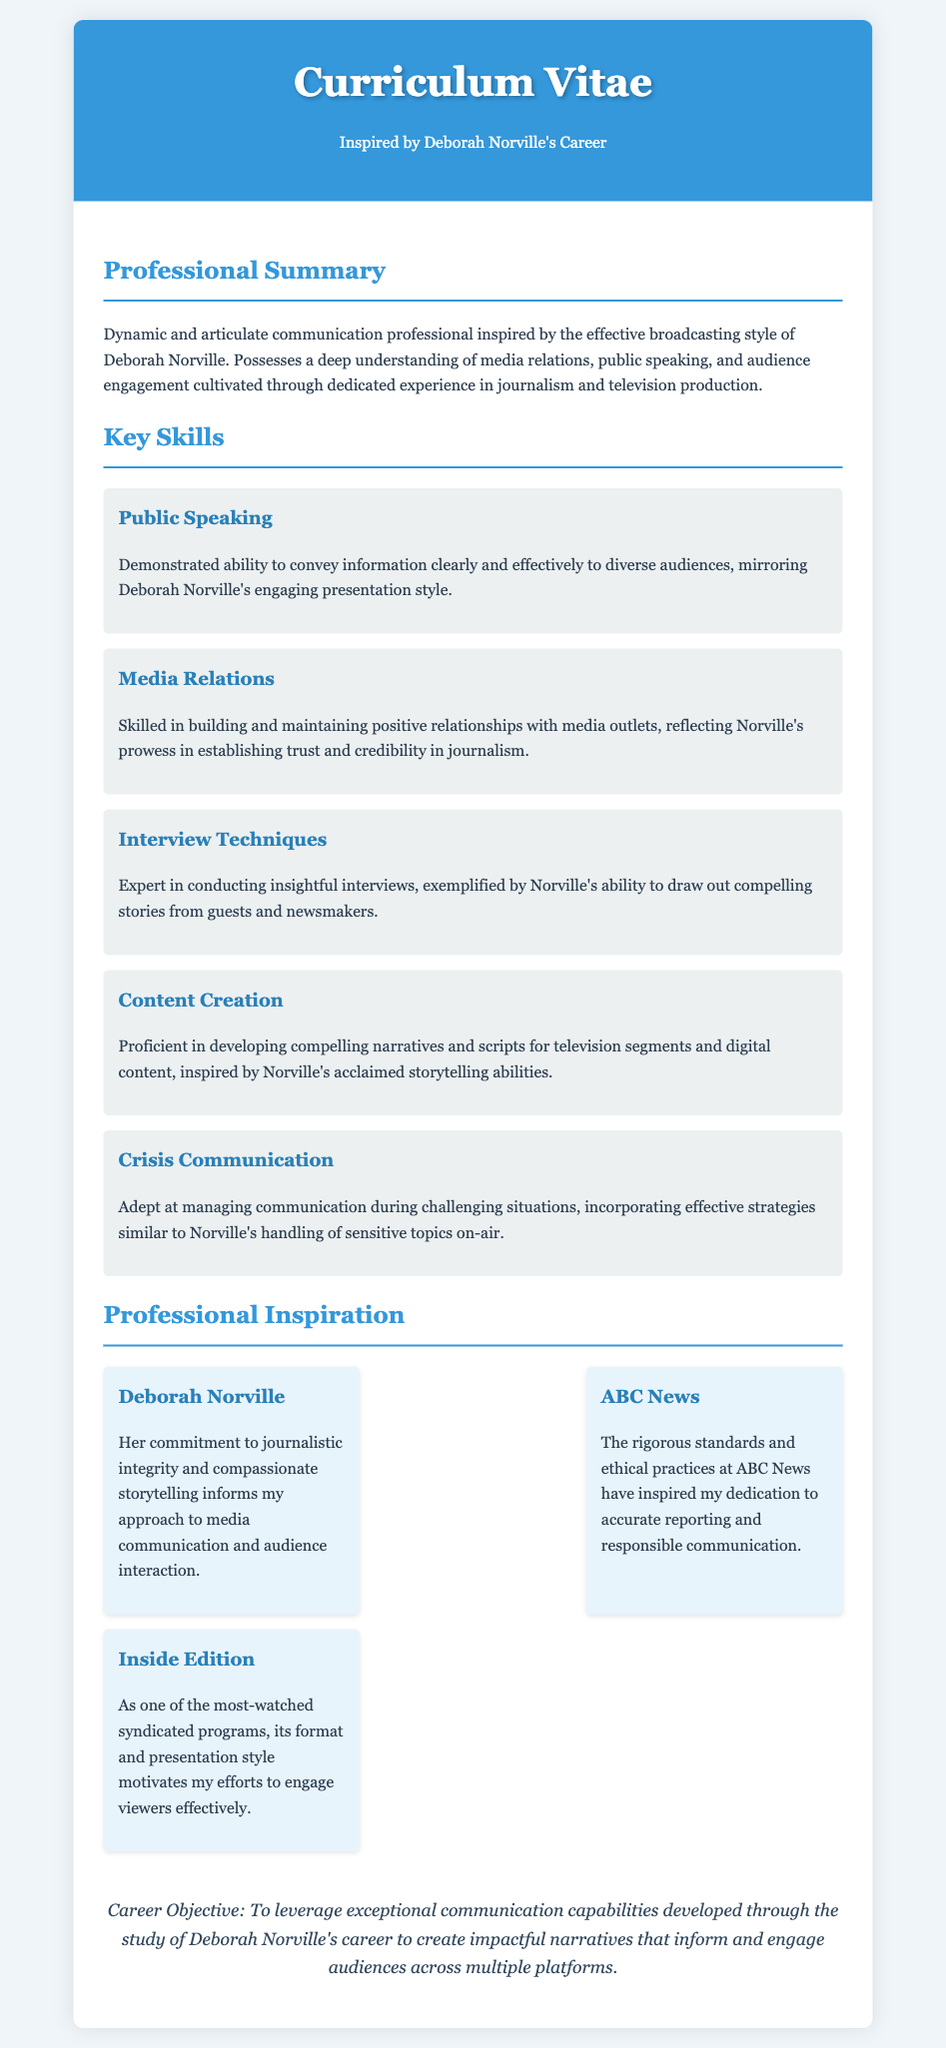What is the title of the document? The title can be found in the main header of the document, which states "Curriculum Vitae".
Answer: Curriculum Vitae Who is the professional inspiration mentioned? Deborah Norville is highlighted as a key professional inspiration, as stated in the "Professional Inspiration" section.
Answer: Deborah Norville What is one of the key skills listed? The key skills are identified under the "Key Skills" section; one example is "Public Speaking".
Answer: Public Speaking How many influences are listed in the document? The document contains a section titled "Professional Inspiration" where three influences are mentioned.
Answer: three What is the primary objective stated in the curriculum vitae? The career objective is summarized in the "Career Objective" section at the end of the document.
Answer: To leverage exceptional communication capabilities What communication skill reflects Norville's presentation style? The skill highlighting clarity and effectiveness in communication is noted in the "Public Speaking" section.
Answer: Public Speaking Which organization's standards influenced the writer's dedication? The influence of "ABC News" is directly mentioned regarding its rigorous standards and ethical practices.
Answer: ABC News What type of content is the writer proficient in creating? The document specifies "television segments and digital content" under the "Content Creation" skill.
Answer: television segments and digital content What does the writer aim to develop through Norville's career study? The objective mentions developing "impactful narratives" that engage audiences as a key goal.
Answer: impactful narratives 